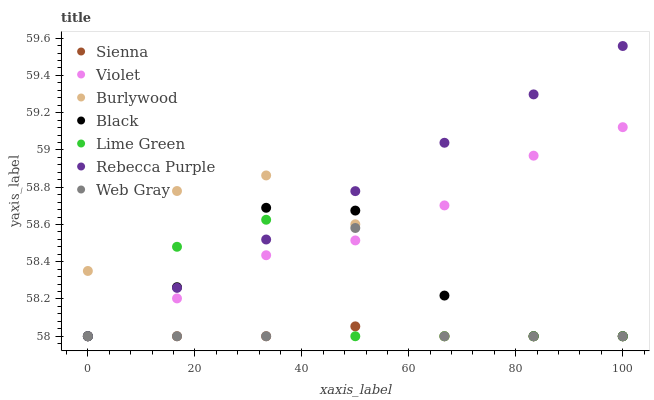Does Sienna have the minimum area under the curve?
Answer yes or no. Yes. Does Rebecca Purple have the maximum area under the curve?
Answer yes or no. Yes. Does Burlywood have the minimum area under the curve?
Answer yes or no. No. Does Burlywood have the maximum area under the curve?
Answer yes or no. No. Is Rebecca Purple the smoothest?
Answer yes or no. Yes. Is Web Gray the roughest?
Answer yes or no. Yes. Is Burlywood the smoothest?
Answer yes or no. No. Is Burlywood the roughest?
Answer yes or no. No. Does Web Gray have the lowest value?
Answer yes or no. Yes. Does Rebecca Purple have the highest value?
Answer yes or no. Yes. Does Burlywood have the highest value?
Answer yes or no. No. Does Violet intersect Web Gray?
Answer yes or no. Yes. Is Violet less than Web Gray?
Answer yes or no. No. Is Violet greater than Web Gray?
Answer yes or no. No. 